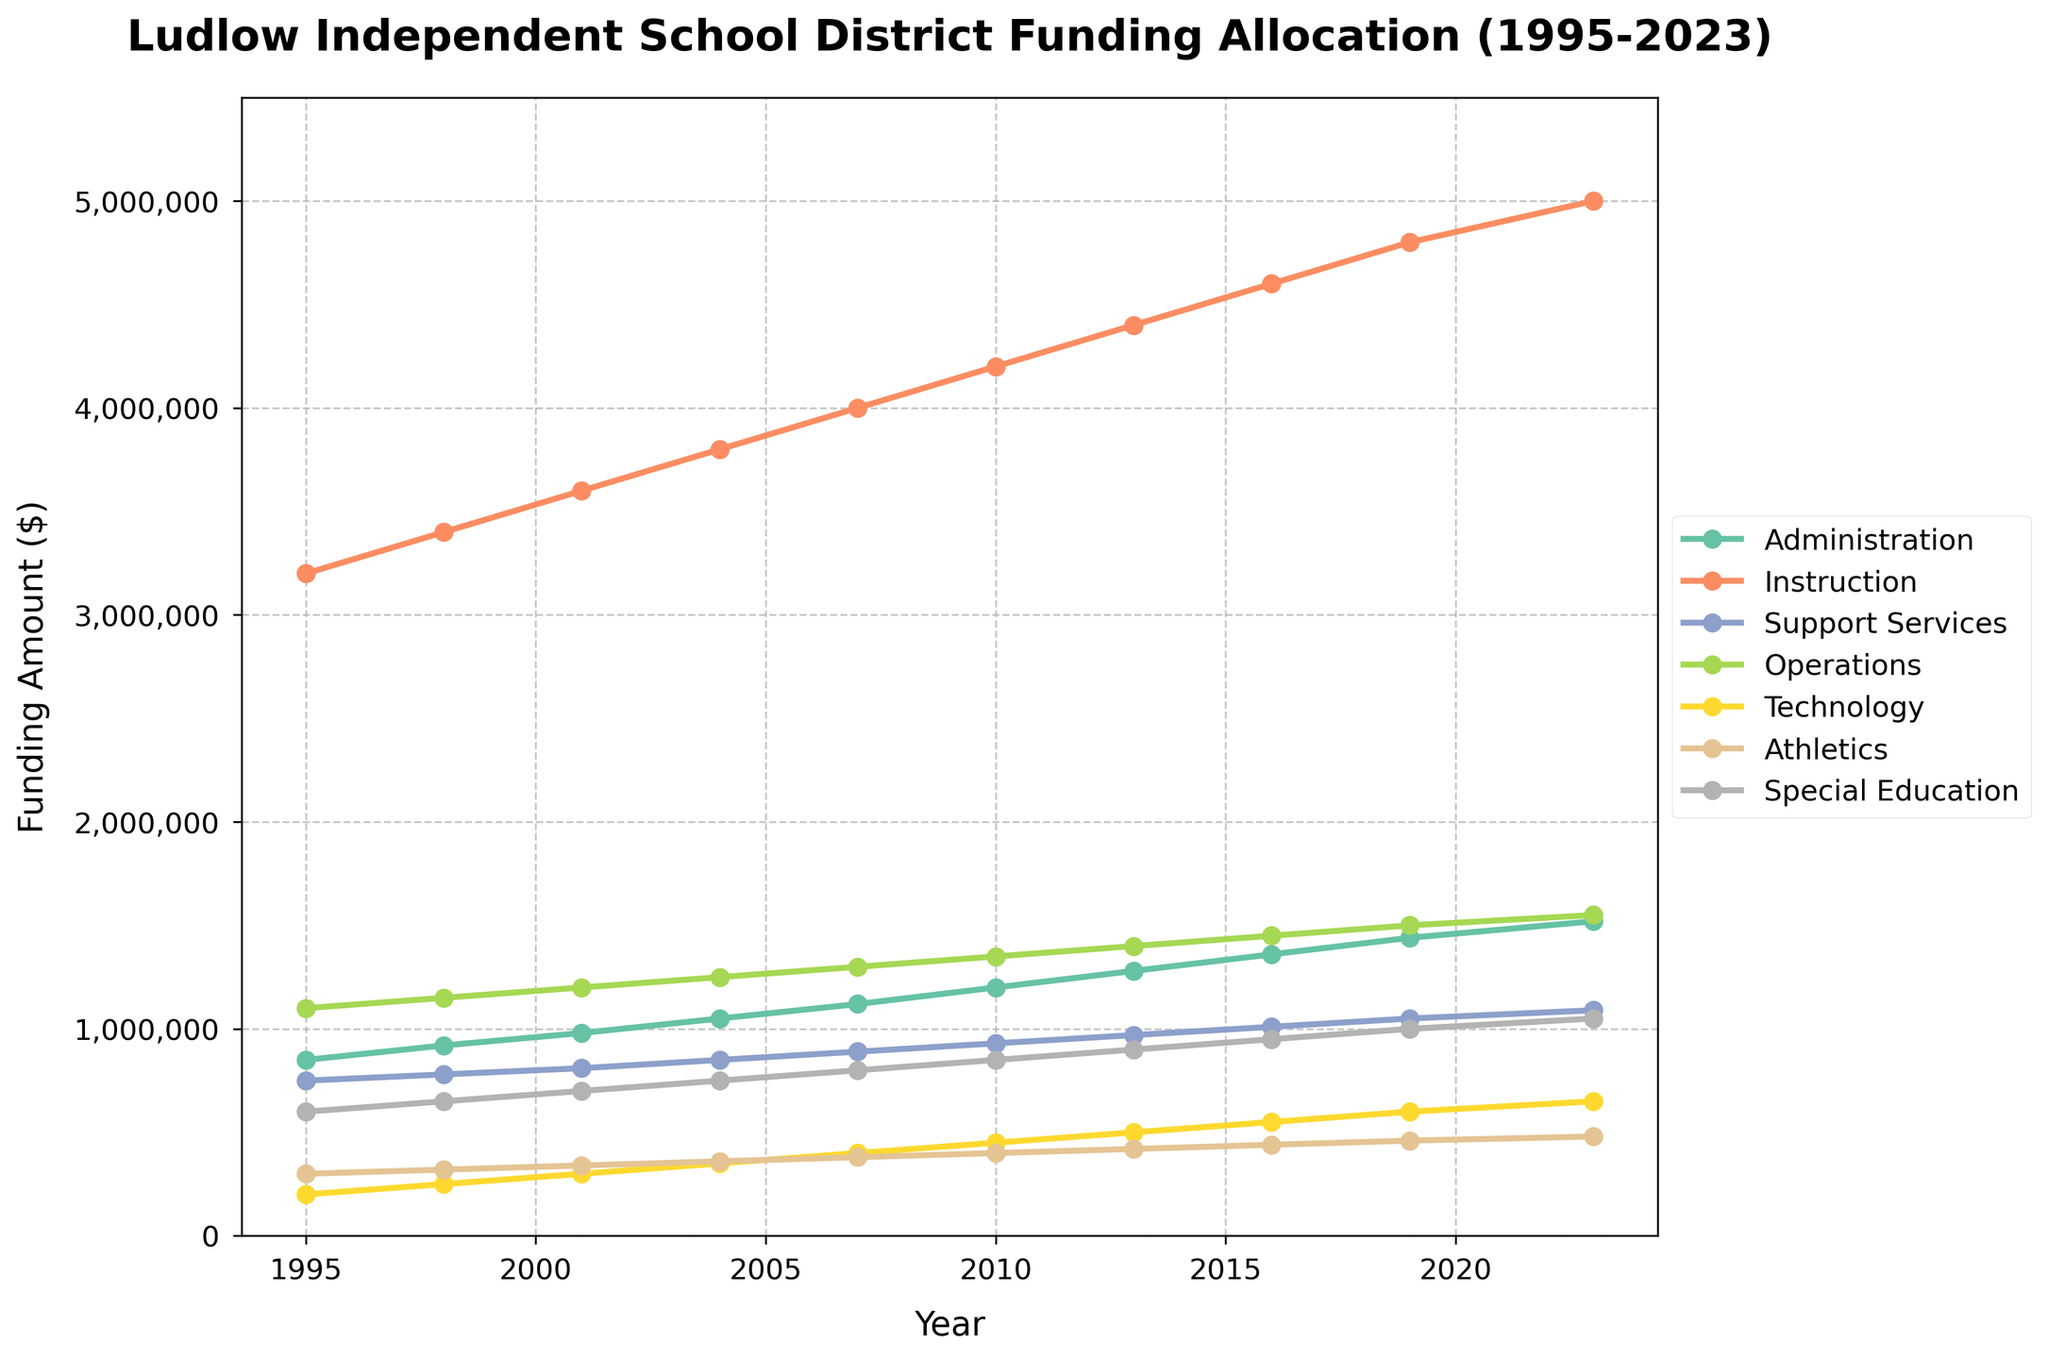Which department received the highest funding in 2023? The line chart shows different funding levels for each department. The 'Instruction' department has the highest point for the year 2023, significantly higher than others, reaching $5,000,000.
Answer: Instruction How much did the funding for Technology increase from 1995 to 2023? Compare the funding for Technology in 1995 and 2023: Funding in 1995 was $200,000 and in 2023 it was $650,000. Subtracting these values gives an increase of $650,000 - $200,000 = $450,000.
Answer: $450,000 What is the total funding allocation across all departments in 1995? Sum all the funding amounts for 1995: $850,000 (Administration) + $3,200,000 (Instruction) + $750,000 (Support Services) + $1,100,000 (Operations) + $200,000 (Technology) + $300,000 (Athletics) + $600,000 (Special Education) = $7,000,000.
Answer: $7,000,000 Which department had the smallest growth in funding from 1995 to 2023? Calculate the differences in funding from 1995 to 2023 for each department: The smallest difference is for Athletics, increasing from $300,000 to $480,000, a difference of $180,000.
Answer: Athletics By how much more did Instruction funding increase compared to Administration funding from 1995 to 2023? Calculate the increase for both: 
Instruction: $5,000,000 (2023) - $3,200,000 (1995) = $1,800,000,
Administration: $1,520,000 (2023) - $850,000 (1995) = $670,000,
Then find the difference: $1,800,000 - $670,000 = $1,130,000.
Answer: $1,130,000 During which year did Operations funding reach $1,500,000? The Operations line reaches $1,500,000 around the year 2019.
Answer: 2019 What is the average funding for Special Education from 1995 to 2023? Sum the Special Education funding values for each year and divide by the number of years:
($600,000 + $650,000 + $700,000 + $750,000 + $800,000 + $850,000 + $900,000 + $950,000 + $1,000,000 + $1,050,000) / 10 = $8,250,000 / 10 = $825,000.
Answer: $825,000 Compare the funding for Athletics and Technology in 2013. Which received more, and by how much? Look at 2013 data: Technology received $500,000, Athletics received $420,000. Technology received more, by $500,000 - $420,000 = $80,000.
Answer: Technology, $80,000 